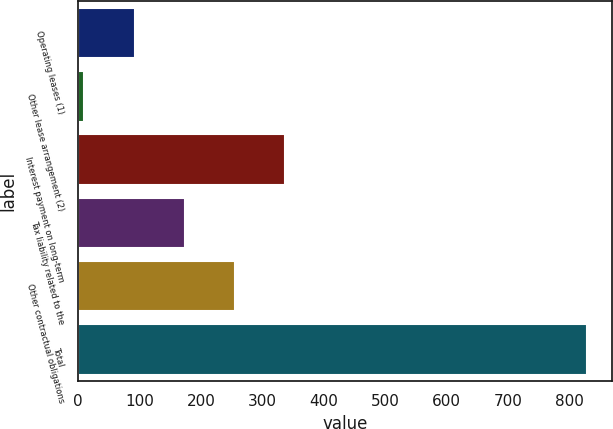<chart> <loc_0><loc_0><loc_500><loc_500><bar_chart><fcel>Operating leases (1)<fcel>Other lease arrangement (2)<fcel>Interest payment on long-term<fcel>Tax liability related to the<fcel>Other contractual obligations<fcel>Total<nl><fcel>91.59<fcel>9.8<fcel>336.96<fcel>173.38<fcel>255.17<fcel>827.7<nl></chart> 